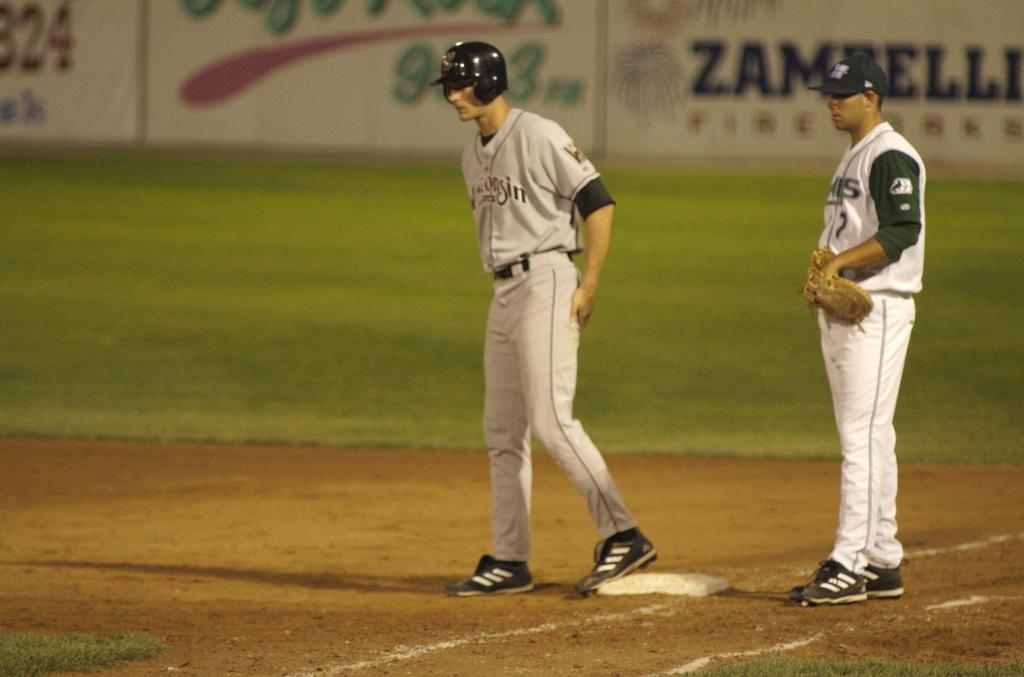What game are they playing?
Keep it short and to the point. Answering does not require reading text in the image. 